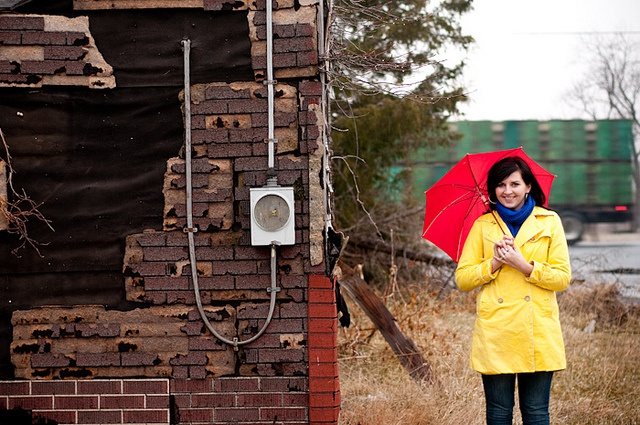Describe the objects in this image and their specific colors. I can see people in gray, gold, khaki, and black tones, truck in gray, teal, and black tones, and umbrella in gray, red, black, and brown tones in this image. 